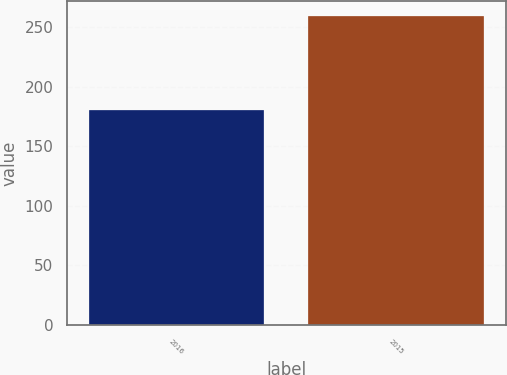Convert chart to OTSL. <chart><loc_0><loc_0><loc_500><loc_500><bar_chart><fcel>2016<fcel>2015<nl><fcel>180.2<fcel>259.1<nl></chart> 